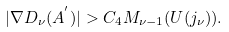<formula> <loc_0><loc_0><loc_500><loc_500>| \nabla D _ { \nu } ( A ^ { ^ { \prime } } ) | > C _ { 4 } M _ { \nu - 1 } ( U ( j _ { \nu } ) ) .</formula> 